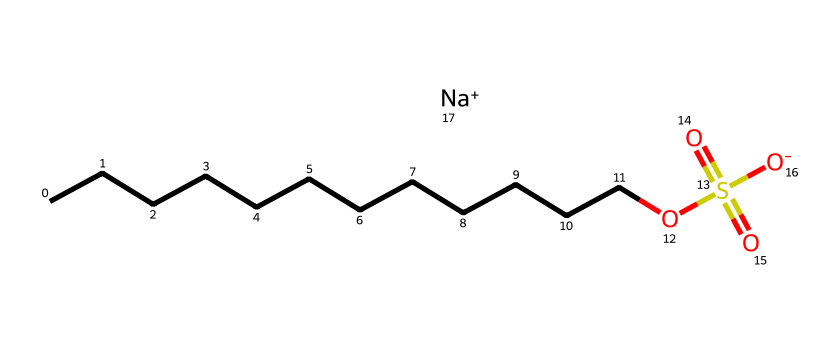how many carbon atoms are present in this chemical? The SMILES notation shows a hydrocarbon chain with 12 'C's represented by "CCCCCCCCCCCC," which indicates there are 12 carbon atoms.
Answer: 12 what functional groups are present in this chemical? The SMILES indicates the presence of a sulfonate group (OS(=O)(=O)[O-]) attached to a long carbon chain, making it a sulfonate detergent.
Answer: sulfonate how many oxygen atoms are there in this compound? The sulfonate group contains 4 oxygen atoms (2 from the sulfate and 2 from the sulfonate) plus 1 attached to the 'S' in the sulfonate structure, leading to a total of 4 oxygen atoms.
Answer: 4 what type of detergent is represented by this chemical structure? The presence of the sulfonate group and the absence of phosphate indicate that this is a phosphate-free detergent, specifically a sulfonate detergent.
Answer: sulfonate detergent is this detergent biodegradable? The long aliphatic carbon chain along with the sulfonate group structure generally indicates that this type of detergent is biodegradable, especially in comparison to phosphate-based detergents.
Answer: yes how many sodium ions are present in this chemical? The notation includes one occurrence of "[Na+]", indicating there is one sodium ion associated with the sulfonate group.
Answer: 1 what property of the carbon chain contributes to the detergent's cleaning ability? The long hydrophobic carbon chain provides the detergent with surfactant properties, allowing it to emulsify oils and grease effectively.
Answer: surfactant properties 